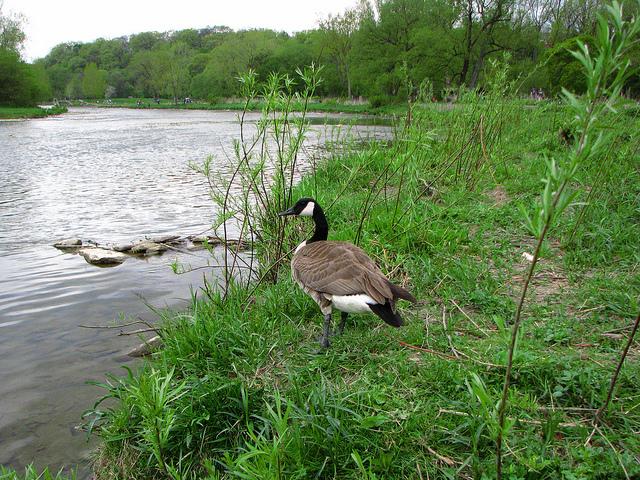Is the animal sitting on more eggs?
Short answer required. No. What kind of bird is this?
Answer briefly. Goose. Is the bird in the water?
Keep it brief. No. What type of body of water is this?
Answer briefly. River. Are both birds the same type of bird?
Concise answer only. Yes. Is the animal going to jump into the water?
Write a very short answer. Yes. What country are the animals in?
Quick response, please. Usa. 